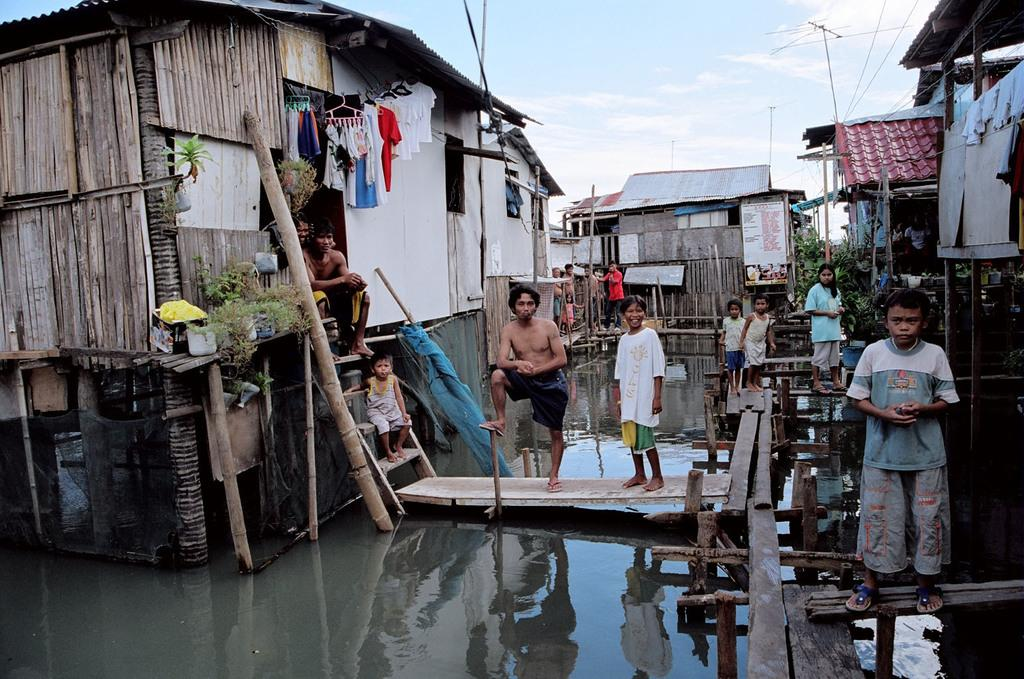What type of structures can be seen in the image? There are houses in the image. What are the people in the image doing? The people are standing on a wooden bridge in the image. What is under the wooden bridge? There is water visible under the wooden bridge. What type of drink is being served in the image? There is no drink visible in the image; it features houses, a wooden bridge, and people standing on it. Can you tell me how many dogs are present in the image? There are no dogs present in the image. 